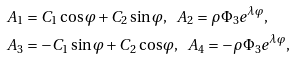Convert formula to latex. <formula><loc_0><loc_0><loc_500><loc_500>& A _ { 1 } = C _ { 1 } \cos \varphi + C _ { 2 } \sin \varphi , \ \ A _ { 2 } = \rho \Phi _ { 3 } e ^ { \lambda \varphi } , \\ & A _ { 3 } = - C _ { 1 } \sin \varphi + C _ { 2 } \cos \varphi , \ \ A _ { 4 } = - \rho \Phi _ { 3 } e ^ { \lambda \varphi } ,</formula> 